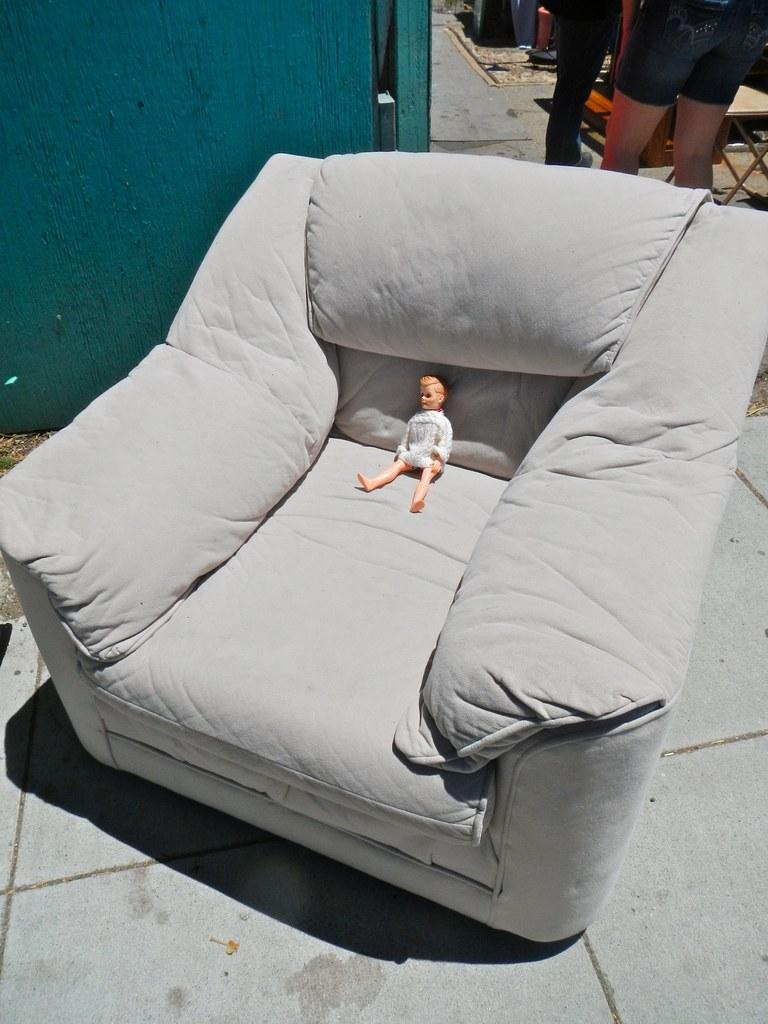What is on the grey sofa in the image? There is a toy on the grey sofa. Can you describe the people behind the sofa? There are two people behind the sofa. What type of mask is the toy wearing in the image? There is no mask present in the image, as the toy is not wearing any clothing or accessories. 